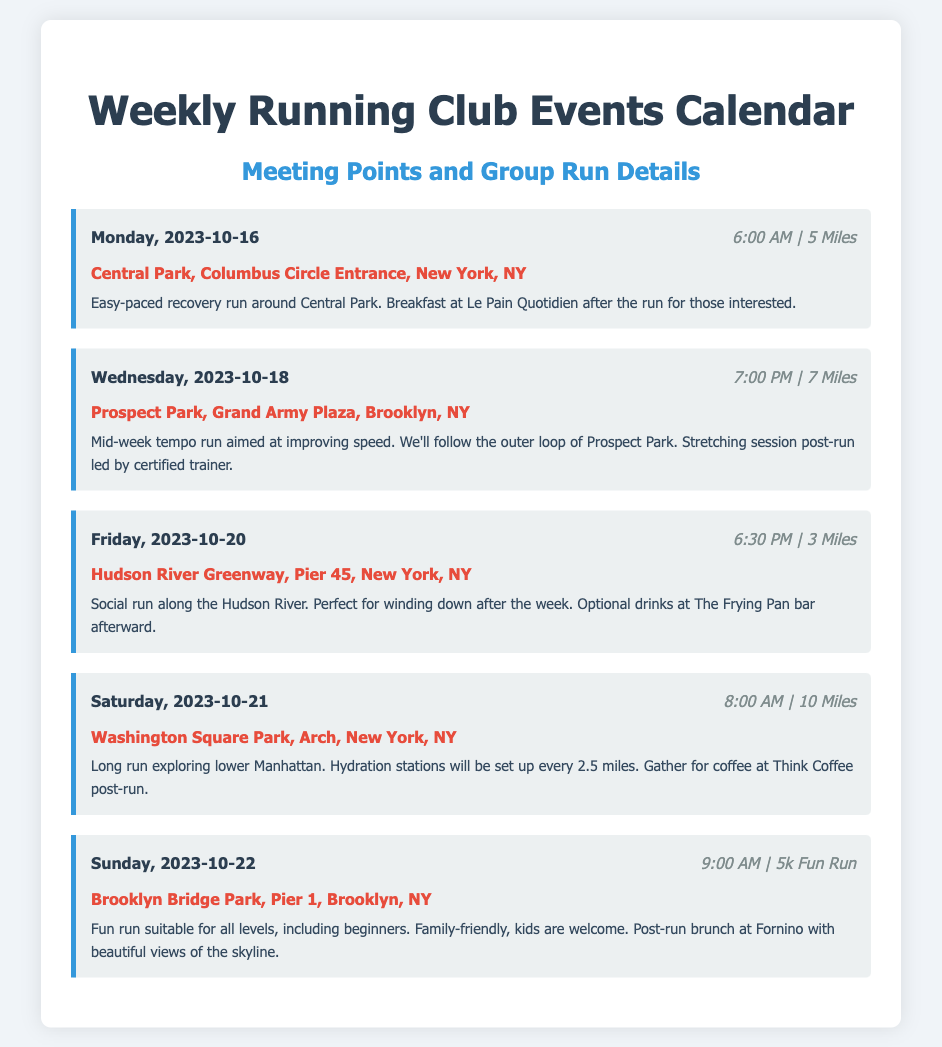what is the meeting point for the run on Monday? The meeting point for Monday's run is listed under the event details, which is Central Park, Columbus Circle Entrance, New York, NY.
Answer: Central Park, Columbus Circle Entrance, New York, NY what is the distance of the long run on Saturday? The distance for the long run on Saturday is found in the corresponding event's time-distance line, which states 10 Miles.
Answer: 10 Miles what time does the Wednesday run start? The starting time for the Wednesday run is specified in the event details as 7:00 PM.
Answer: 7:00 PM how many miles will runners cover on the Sunday fun run? The distance for the fun run on Sunday is indicated as 5k, which corresponds to kilometers.
Answer: 5k what type of run is scheduled for Friday? The type of run for Friday is described in the event details, which states it is a social run along the Hudson River.
Answer: Social run how many hydration stations will be available on Saturday? The details for the Saturday run mention that hydration stations will be set up every 2.5 miles, but a specific number isn't given.
Answer: (not explicitly mentioned) based on the document, what is being offered after the Monday run? The details mention breakfast at Le Pain Quotidien after the run for those interested, indicating a social aspect.
Answer: Breakfast at Le Pain Quotidien which event includes a stretching session? The event details for Wednesday mention a stretching session post-run led by a certified trainer, indicating this specific event includes it.
Answer: Wednesday is the Sunday fun run family-friendly? The details explicitly state that the Sunday fun run is suitable for all levels, including beginners, and specifically mentions that kids are welcome.
Answer: Yes 